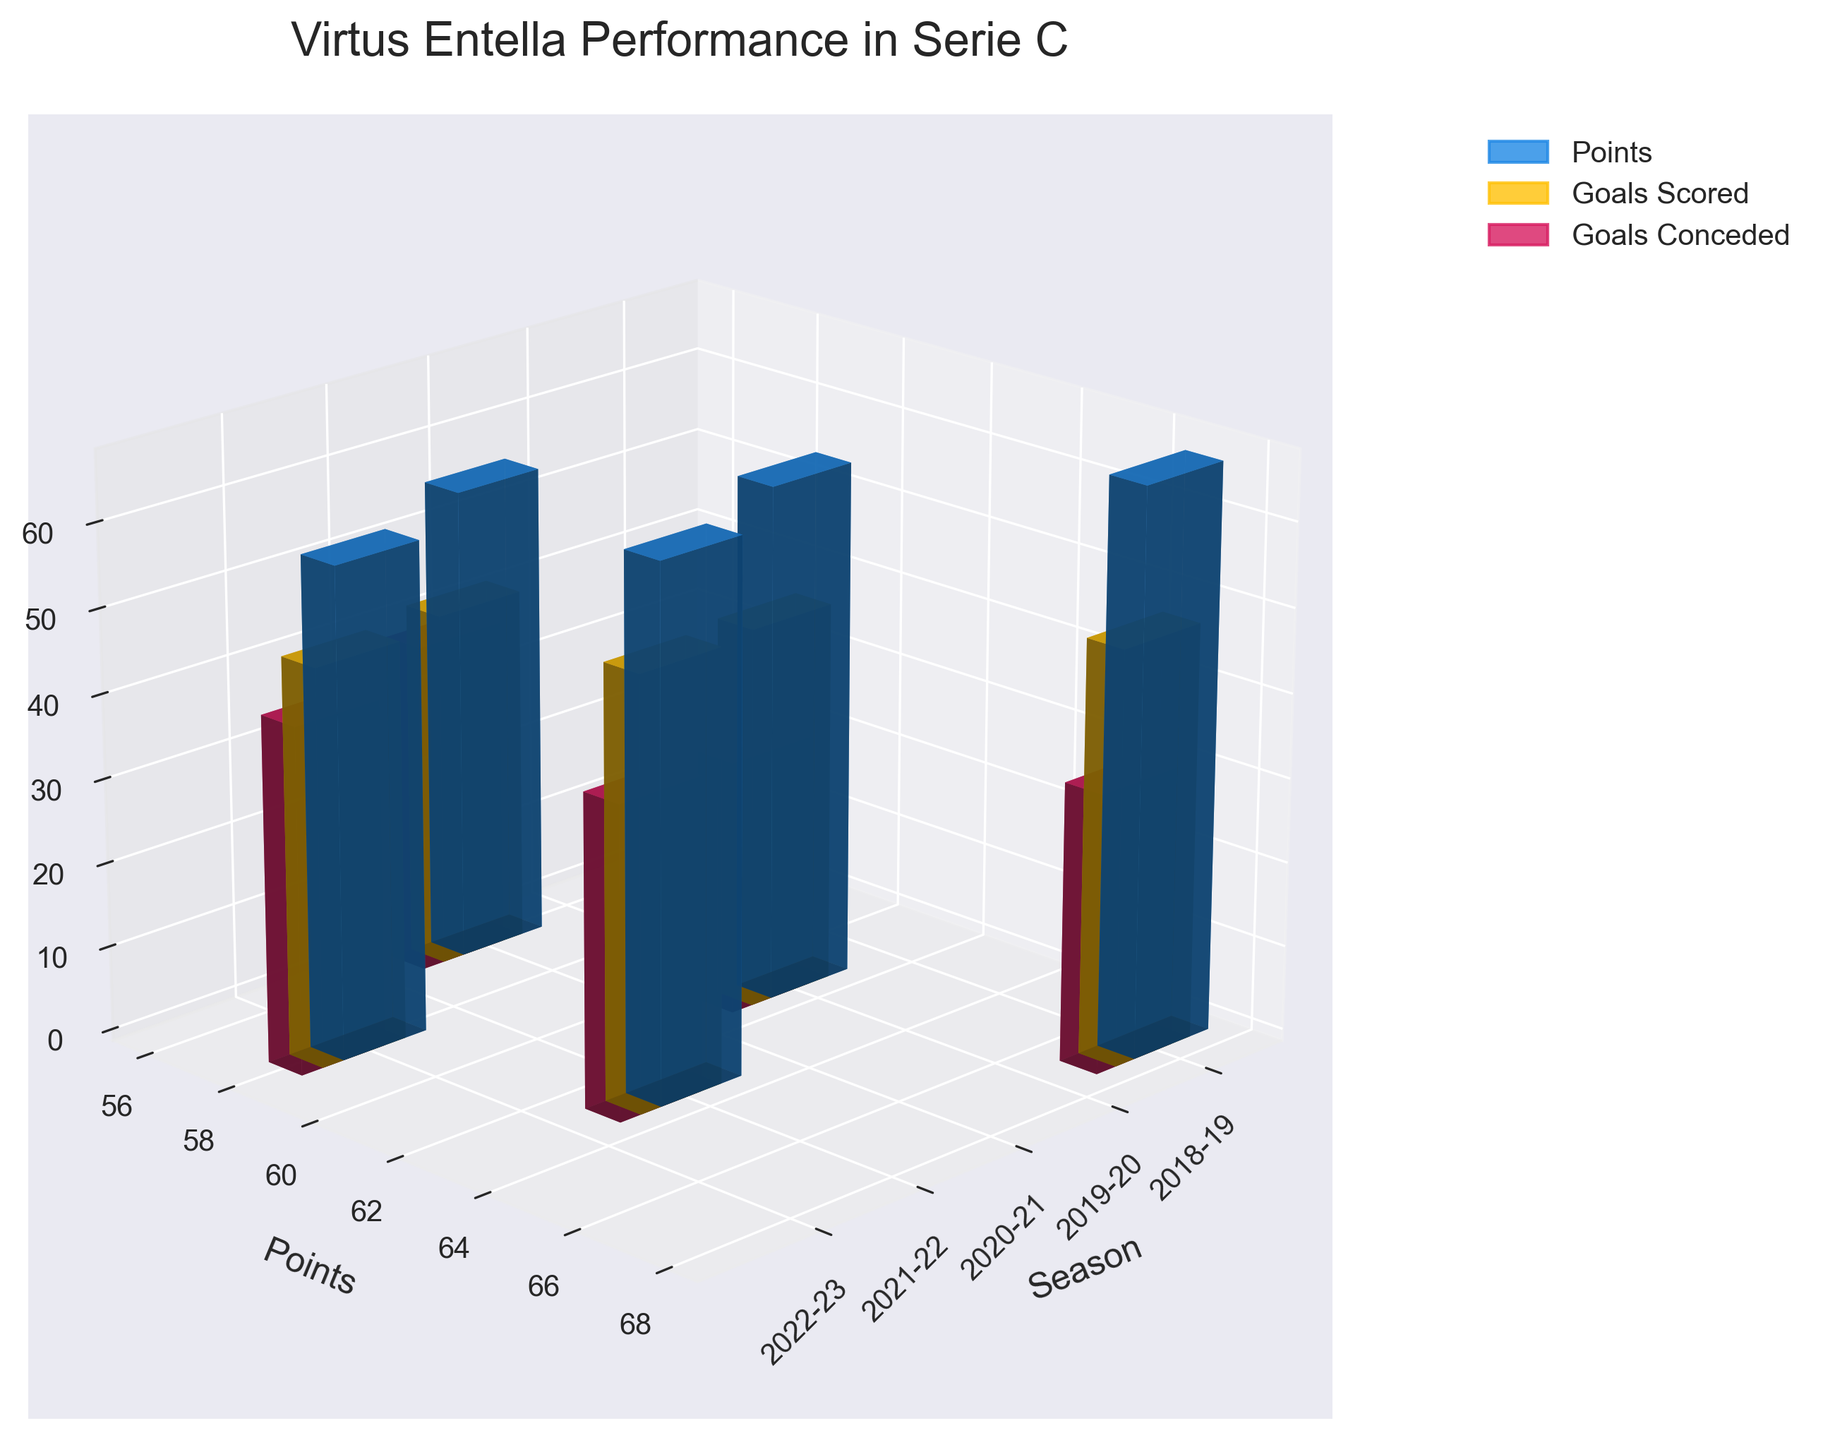what is the title of the figure? The title is usually placed at the top of the figure, easily identifiable by its size and position. In this figure, the title is "Virtus Entella Performance in Serie C".
Answer: Virtus Entella Performance in Serie C What is the range of the 'Points' axis? The 'Points' axis is the y-axis in this figure. The range is determined by observing the minimum and maximum values marked on the axis. This axis goes from 0 to a slightly higher number than the maximum points in the dataset, so it spans from approximately 0 to 70.
Answer: 0 to 70 In which season did Virtus Entella score the most goals? To find the season with the most goals, look for the tallest yellow bar (which represents 'Goals Scored') among all the seasons. The season with the highest yellow bar is 2021-22.
Answer: 2021-22 How many seasons are included in this plot? The number of seasons can be obtained by counting the unique x-tick labels, which correspond to the different seasons. There are 5 x-tick labels representing 5 seasons.
Answer: 5 Which season had the highest points? The season with the highest points is represented by the tallest blue bar. By visually inspecting, the tallest blue bar is in the 2018-19 season.
Answer: 2018-19 Between the 2019-20 and 2022-23 seasons, which one had more goals scored? Compare the heights of the yellow bars for the 2019-20 and 2022-23 seasons. The yellow bar for 2022-23 is taller than for 2019-20, indicating more goals scored.
Answer: 2022-23 Which seasons had more than 60 points? Identify the seasons where the blue bars (points) exceed the 60 mark on the y-axis. The seasons 2018-19 and 2021-22 both exceed 60 points.
Answer: 2018-19, 2021-22 How many goals did Virtus Entella concede in the 2020-21 season? The goals conceded are represented by the red bars. Locate the red bar for the 2020-21 season and read its value. The height of the red bar for 2020-21 is 39.
Answer: 39 What is the average number of goals conceded across all seasons? Sum all the goals conceded across the seasons (33 + 30 + 39 + 37 + 41) and divide by the number of seasons (5). (33 + 30 + 39 + 37 + 41) = 180, and 180 / 5 = 36.
Answer: 36 During which season did Virtus Entella have the smallest difference between goals scored and goals conceded? Calculate the difference between the heights of the yellow and red bars for each season. The smallest difference is found where the bars are closest in height, which is in the 2019-20 season with a difference of 15 (45 - 30 = 15).
Answer: 2019-20 